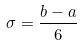Convert formula to latex. <formula><loc_0><loc_0><loc_500><loc_500>\sigma = \frac { b - a } { 6 }</formula> 